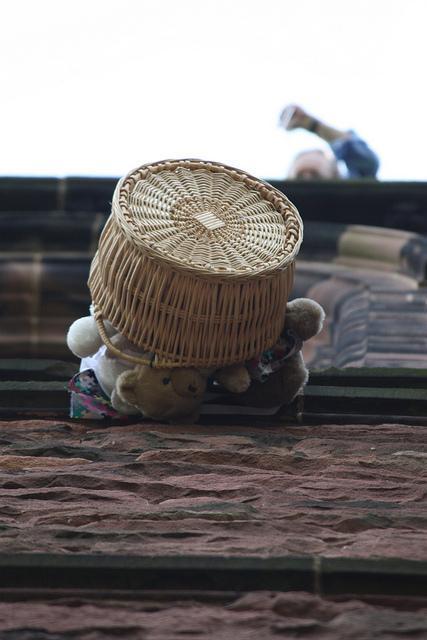What is the wicker basket covering on top of?
Indicate the correct response and explain using: 'Answer: answer
Rationale: rationale.'
Options: Fruits, head, teddy bears, vegetables. Answer: teddy bears.
Rationale: The basket covers teddy bears. 